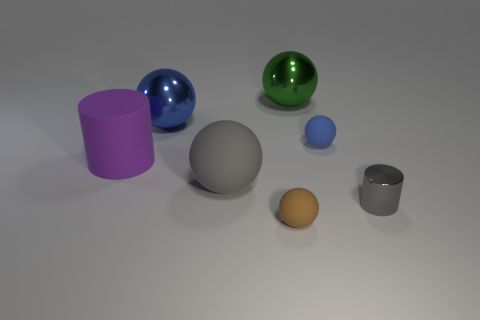There is a thing that is left of the big gray object and in front of the blue rubber object; what color is it?
Ensure brevity in your answer.  Purple. Are there any other tiny cylinders that have the same color as the tiny cylinder?
Your answer should be very brief. No. There is a metal thing in front of the large blue shiny thing; what is its color?
Provide a succinct answer. Gray. There is a blue object that is right of the big green shiny thing; is there a gray shiny cylinder that is behind it?
Offer a terse response. No. Is the color of the shiny cylinder the same as the cylinder to the left of the green metallic thing?
Your response must be concise. No. Is there a red ball made of the same material as the tiny gray cylinder?
Provide a short and direct response. No. What number of large cyan cylinders are there?
Make the answer very short. 0. There is a tiny gray thing in front of the blue thing that is on the left side of the big gray ball; what is its material?
Your answer should be compact. Metal. There is a large thing that is made of the same material as the large gray ball; what is its color?
Your answer should be very brief. Purple. The other thing that is the same color as the small metal object is what shape?
Your answer should be very brief. Sphere. 